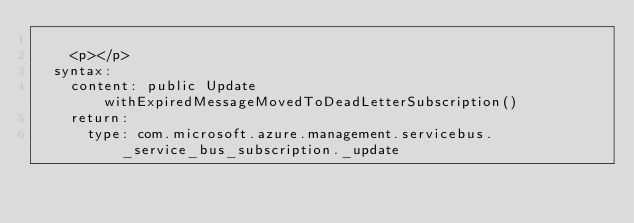<code> <loc_0><loc_0><loc_500><loc_500><_YAML_>
    <p></p>
  syntax:
    content: public Update withExpiredMessageMovedToDeadLetterSubscription()
    return:
      type: com.microsoft.azure.management.servicebus._service_bus_subscription._update</code> 